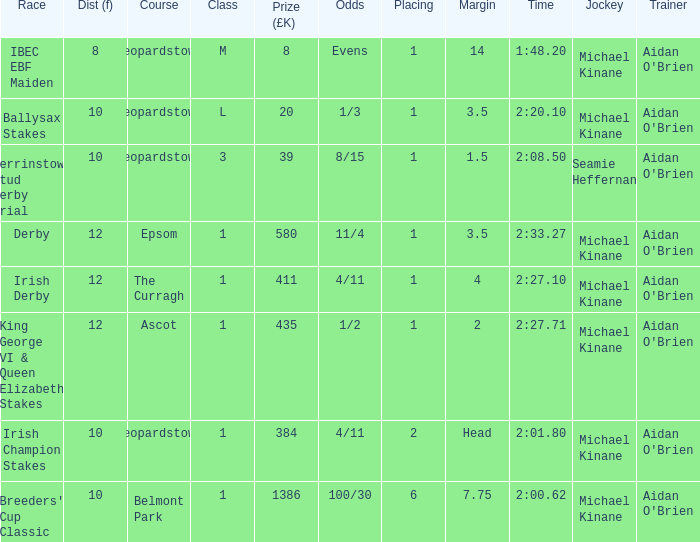Which Class has a Jockey of michael kinane on 2:27.71? 1.0. 